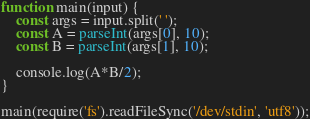<code> <loc_0><loc_0><loc_500><loc_500><_JavaScript_>function main(input) {
    const args = input.split(' ');
    const A = parseInt(args[0], 10);
    const B = parseInt(args[1], 10);

    console.log(A*B/2);
}

main(require('fs').readFileSync('/dev/stdin', 'utf8'));
</code> 